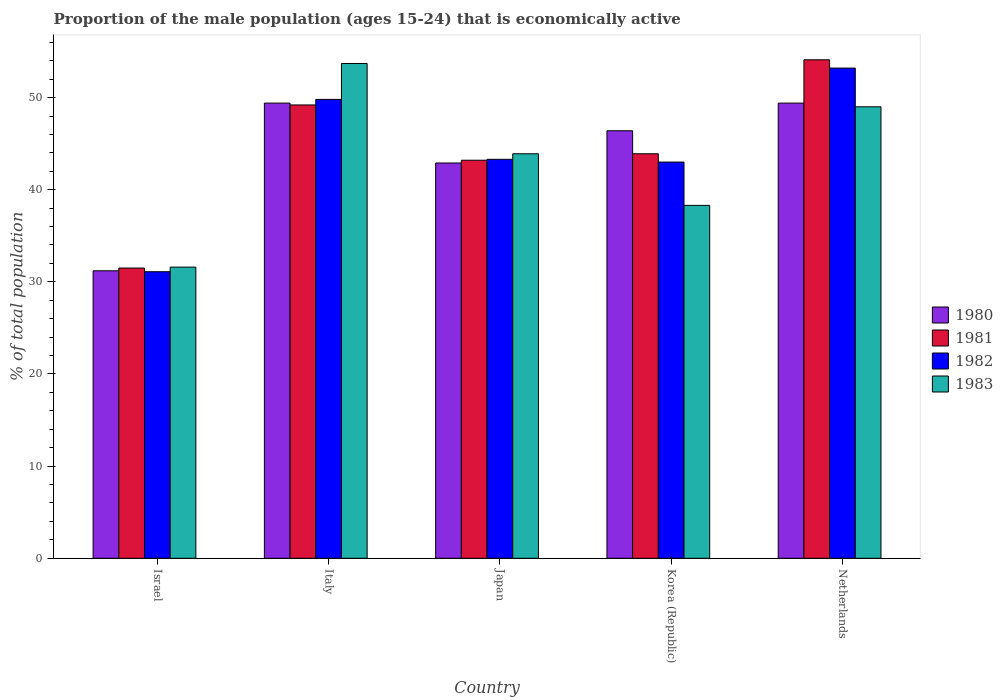How many groups of bars are there?
Offer a very short reply. 5. Are the number of bars per tick equal to the number of legend labels?
Your response must be concise. Yes. How many bars are there on the 1st tick from the left?
Your response must be concise. 4. What is the label of the 2nd group of bars from the left?
Your answer should be very brief. Italy. In how many cases, is the number of bars for a given country not equal to the number of legend labels?
Offer a terse response. 0. Across all countries, what is the maximum proportion of the male population that is economically active in 1981?
Make the answer very short. 54.1. Across all countries, what is the minimum proportion of the male population that is economically active in 1982?
Offer a terse response. 31.1. In which country was the proportion of the male population that is economically active in 1982 maximum?
Your response must be concise. Netherlands. What is the total proportion of the male population that is economically active in 1980 in the graph?
Make the answer very short. 219.3. What is the difference between the proportion of the male population that is economically active in 1980 in Israel and that in Japan?
Your answer should be compact. -11.7. What is the difference between the proportion of the male population that is economically active in 1983 in Netherlands and the proportion of the male population that is economically active in 1981 in Italy?
Offer a very short reply. -0.2. What is the average proportion of the male population that is economically active in 1980 per country?
Ensure brevity in your answer.  43.86. What is the difference between the proportion of the male population that is economically active of/in 1983 and proportion of the male population that is economically active of/in 1982 in Korea (Republic)?
Provide a short and direct response. -4.7. What is the ratio of the proportion of the male population that is economically active in 1982 in Italy to that in Netherlands?
Provide a succinct answer. 0.94. Is the proportion of the male population that is economically active in 1981 in Italy less than that in Japan?
Keep it short and to the point. No. Is the difference between the proportion of the male population that is economically active in 1983 in Israel and Japan greater than the difference between the proportion of the male population that is economically active in 1982 in Israel and Japan?
Provide a short and direct response. No. What is the difference between the highest and the second highest proportion of the male population that is economically active in 1982?
Ensure brevity in your answer.  6.5. What is the difference between the highest and the lowest proportion of the male population that is economically active in 1980?
Ensure brevity in your answer.  18.2. In how many countries, is the proportion of the male population that is economically active in 1982 greater than the average proportion of the male population that is economically active in 1982 taken over all countries?
Provide a short and direct response. 2. Is it the case that in every country, the sum of the proportion of the male population that is economically active in 1982 and proportion of the male population that is economically active in 1981 is greater than the sum of proportion of the male population that is economically active in 1983 and proportion of the male population that is economically active in 1980?
Make the answer very short. No. What does the 4th bar from the left in Japan represents?
Provide a short and direct response. 1983. What does the 3rd bar from the right in Korea (Republic) represents?
Your answer should be compact. 1981. Are all the bars in the graph horizontal?
Provide a succinct answer. No. Are the values on the major ticks of Y-axis written in scientific E-notation?
Provide a succinct answer. No. Does the graph contain any zero values?
Keep it short and to the point. No. Where does the legend appear in the graph?
Keep it short and to the point. Center right. How are the legend labels stacked?
Offer a terse response. Vertical. What is the title of the graph?
Keep it short and to the point. Proportion of the male population (ages 15-24) that is economically active. What is the label or title of the X-axis?
Your answer should be compact. Country. What is the label or title of the Y-axis?
Your response must be concise. % of total population. What is the % of total population of 1980 in Israel?
Offer a terse response. 31.2. What is the % of total population in 1981 in Israel?
Your answer should be compact. 31.5. What is the % of total population in 1982 in Israel?
Your response must be concise. 31.1. What is the % of total population of 1983 in Israel?
Provide a succinct answer. 31.6. What is the % of total population in 1980 in Italy?
Provide a short and direct response. 49.4. What is the % of total population in 1981 in Italy?
Your answer should be compact. 49.2. What is the % of total population in 1982 in Italy?
Your answer should be very brief. 49.8. What is the % of total population of 1983 in Italy?
Ensure brevity in your answer.  53.7. What is the % of total population in 1980 in Japan?
Provide a succinct answer. 42.9. What is the % of total population in 1981 in Japan?
Your answer should be very brief. 43.2. What is the % of total population in 1982 in Japan?
Your answer should be compact. 43.3. What is the % of total population of 1983 in Japan?
Your response must be concise. 43.9. What is the % of total population in 1980 in Korea (Republic)?
Provide a succinct answer. 46.4. What is the % of total population in 1981 in Korea (Republic)?
Offer a terse response. 43.9. What is the % of total population in 1983 in Korea (Republic)?
Ensure brevity in your answer.  38.3. What is the % of total population in 1980 in Netherlands?
Ensure brevity in your answer.  49.4. What is the % of total population in 1981 in Netherlands?
Your answer should be very brief. 54.1. What is the % of total population in 1982 in Netherlands?
Give a very brief answer. 53.2. What is the % of total population of 1983 in Netherlands?
Make the answer very short. 49. Across all countries, what is the maximum % of total population of 1980?
Your response must be concise. 49.4. Across all countries, what is the maximum % of total population of 1981?
Offer a very short reply. 54.1. Across all countries, what is the maximum % of total population in 1982?
Ensure brevity in your answer.  53.2. Across all countries, what is the maximum % of total population of 1983?
Offer a very short reply. 53.7. Across all countries, what is the minimum % of total population in 1980?
Provide a short and direct response. 31.2. Across all countries, what is the minimum % of total population of 1981?
Keep it short and to the point. 31.5. Across all countries, what is the minimum % of total population in 1982?
Provide a short and direct response. 31.1. Across all countries, what is the minimum % of total population in 1983?
Offer a terse response. 31.6. What is the total % of total population in 1980 in the graph?
Your response must be concise. 219.3. What is the total % of total population in 1981 in the graph?
Offer a very short reply. 221.9. What is the total % of total population in 1982 in the graph?
Your answer should be very brief. 220.4. What is the total % of total population in 1983 in the graph?
Ensure brevity in your answer.  216.5. What is the difference between the % of total population in 1980 in Israel and that in Italy?
Ensure brevity in your answer.  -18.2. What is the difference between the % of total population of 1981 in Israel and that in Italy?
Give a very brief answer. -17.7. What is the difference between the % of total population of 1982 in Israel and that in Italy?
Your response must be concise. -18.7. What is the difference between the % of total population of 1983 in Israel and that in Italy?
Your response must be concise. -22.1. What is the difference between the % of total population in 1982 in Israel and that in Japan?
Ensure brevity in your answer.  -12.2. What is the difference between the % of total population in 1983 in Israel and that in Japan?
Give a very brief answer. -12.3. What is the difference between the % of total population of 1980 in Israel and that in Korea (Republic)?
Keep it short and to the point. -15.2. What is the difference between the % of total population in 1981 in Israel and that in Korea (Republic)?
Your answer should be compact. -12.4. What is the difference between the % of total population in 1982 in Israel and that in Korea (Republic)?
Make the answer very short. -11.9. What is the difference between the % of total population in 1983 in Israel and that in Korea (Republic)?
Your answer should be compact. -6.7. What is the difference between the % of total population of 1980 in Israel and that in Netherlands?
Provide a short and direct response. -18.2. What is the difference between the % of total population in 1981 in Israel and that in Netherlands?
Ensure brevity in your answer.  -22.6. What is the difference between the % of total population in 1982 in Israel and that in Netherlands?
Provide a succinct answer. -22.1. What is the difference between the % of total population of 1983 in Israel and that in Netherlands?
Make the answer very short. -17.4. What is the difference between the % of total population of 1981 in Italy and that in Japan?
Provide a short and direct response. 6. What is the difference between the % of total population in 1982 in Italy and that in Japan?
Keep it short and to the point. 6.5. What is the difference between the % of total population in 1983 in Italy and that in Japan?
Make the answer very short. 9.8. What is the difference between the % of total population in 1980 in Italy and that in Korea (Republic)?
Ensure brevity in your answer.  3. What is the difference between the % of total population of 1982 in Italy and that in Korea (Republic)?
Ensure brevity in your answer.  6.8. What is the difference between the % of total population of 1982 in Italy and that in Netherlands?
Make the answer very short. -3.4. What is the difference between the % of total population in 1983 in Italy and that in Netherlands?
Your answer should be very brief. 4.7. What is the difference between the % of total population in 1980 in Japan and that in Korea (Republic)?
Offer a very short reply. -3.5. What is the difference between the % of total population in 1982 in Japan and that in Korea (Republic)?
Offer a terse response. 0.3. What is the difference between the % of total population of 1983 in Japan and that in Korea (Republic)?
Your answer should be compact. 5.6. What is the difference between the % of total population in 1980 in Japan and that in Netherlands?
Make the answer very short. -6.5. What is the difference between the % of total population of 1981 in Japan and that in Netherlands?
Your response must be concise. -10.9. What is the difference between the % of total population of 1982 in Japan and that in Netherlands?
Provide a short and direct response. -9.9. What is the difference between the % of total population of 1983 in Japan and that in Netherlands?
Ensure brevity in your answer.  -5.1. What is the difference between the % of total population in 1980 in Korea (Republic) and that in Netherlands?
Offer a very short reply. -3. What is the difference between the % of total population in 1982 in Korea (Republic) and that in Netherlands?
Ensure brevity in your answer.  -10.2. What is the difference between the % of total population of 1983 in Korea (Republic) and that in Netherlands?
Provide a succinct answer. -10.7. What is the difference between the % of total population in 1980 in Israel and the % of total population in 1981 in Italy?
Ensure brevity in your answer.  -18. What is the difference between the % of total population in 1980 in Israel and the % of total population in 1982 in Italy?
Keep it short and to the point. -18.6. What is the difference between the % of total population in 1980 in Israel and the % of total population in 1983 in Italy?
Your answer should be very brief. -22.5. What is the difference between the % of total population of 1981 in Israel and the % of total population of 1982 in Italy?
Your answer should be very brief. -18.3. What is the difference between the % of total population in 1981 in Israel and the % of total population in 1983 in Italy?
Your answer should be compact. -22.2. What is the difference between the % of total population of 1982 in Israel and the % of total population of 1983 in Italy?
Give a very brief answer. -22.6. What is the difference between the % of total population in 1980 in Israel and the % of total population in 1982 in Japan?
Ensure brevity in your answer.  -12.1. What is the difference between the % of total population in 1981 in Israel and the % of total population in 1982 in Japan?
Offer a terse response. -11.8. What is the difference between the % of total population in 1982 in Israel and the % of total population in 1983 in Japan?
Offer a very short reply. -12.8. What is the difference between the % of total population of 1980 in Israel and the % of total population of 1981 in Korea (Republic)?
Your response must be concise. -12.7. What is the difference between the % of total population in 1980 in Israel and the % of total population in 1983 in Korea (Republic)?
Ensure brevity in your answer.  -7.1. What is the difference between the % of total population of 1981 in Israel and the % of total population of 1982 in Korea (Republic)?
Make the answer very short. -11.5. What is the difference between the % of total population in 1981 in Israel and the % of total population in 1983 in Korea (Republic)?
Offer a terse response. -6.8. What is the difference between the % of total population of 1982 in Israel and the % of total population of 1983 in Korea (Republic)?
Offer a terse response. -7.2. What is the difference between the % of total population of 1980 in Israel and the % of total population of 1981 in Netherlands?
Your answer should be compact. -22.9. What is the difference between the % of total population in 1980 in Israel and the % of total population in 1983 in Netherlands?
Ensure brevity in your answer.  -17.8. What is the difference between the % of total population in 1981 in Israel and the % of total population in 1982 in Netherlands?
Ensure brevity in your answer.  -21.7. What is the difference between the % of total population in 1981 in Israel and the % of total population in 1983 in Netherlands?
Make the answer very short. -17.5. What is the difference between the % of total population of 1982 in Israel and the % of total population of 1983 in Netherlands?
Your answer should be very brief. -17.9. What is the difference between the % of total population of 1980 in Italy and the % of total population of 1981 in Japan?
Offer a very short reply. 6.2. What is the difference between the % of total population in 1980 in Italy and the % of total population in 1983 in Japan?
Give a very brief answer. 5.5. What is the difference between the % of total population of 1982 in Italy and the % of total population of 1983 in Japan?
Your answer should be very brief. 5.9. What is the difference between the % of total population in 1980 in Italy and the % of total population in 1983 in Korea (Republic)?
Your response must be concise. 11.1. What is the difference between the % of total population of 1981 in Italy and the % of total population of 1983 in Korea (Republic)?
Your answer should be compact. 10.9. What is the difference between the % of total population of 1982 in Italy and the % of total population of 1983 in Korea (Republic)?
Ensure brevity in your answer.  11.5. What is the difference between the % of total population of 1980 in Italy and the % of total population of 1981 in Netherlands?
Your answer should be compact. -4.7. What is the difference between the % of total population of 1980 in Italy and the % of total population of 1983 in Netherlands?
Make the answer very short. 0.4. What is the difference between the % of total population of 1981 in Italy and the % of total population of 1983 in Netherlands?
Provide a short and direct response. 0.2. What is the difference between the % of total population in 1980 in Japan and the % of total population in 1981 in Korea (Republic)?
Keep it short and to the point. -1. What is the difference between the % of total population of 1981 in Japan and the % of total population of 1982 in Korea (Republic)?
Your response must be concise. 0.2. What is the difference between the % of total population of 1982 in Japan and the % of total population of 1983 in Korea (Republic)?
Ensure brevity in your answer.  5. What is the difference between the % of total population in 1980 in Japan and the % of total population in 1982 in Netherlands?
Provide a short and direct response. -10.3. What is the difference between the % of total population in 1980 in Japan and the % of total population in 1983 in Netherlands?
Your answer should be very brief. -6.1. What is the difference between the % of total population in 1982 in Japan and the % of total population in 1983 in Netherlands?
Provide a short and direct response. -5.7. What is the difference between the % of total population of 1980 in Korea (Republic) and the % of total population of 1982 in Netherlands?
Give a very brief answer. -6.8. What is the difference between the % of total population of 1981 in Korea (Republic) and the % of total population of 1982 in Netherlands?
Keep it short and to the point. -9.3. What is the difference between the % of total population of 1982 in Korea (Republic) and the % of total population of 1983 in Netherlands?
Keep it short and to the point. -6. What is the average % of total population in 1980 per country?
Make the answer very short. 43.86. What is the average % of total population of 1981 per country?
Give a very brief answer. 44.38. What is the average % of total population in 1982 per country?
Your response must be concise. 44.08. What is the average % of total population of 1983 per country?
Give a very brief answer. 43.3. What is the difference between the % of total population in 1981 and % of total population in 1983 in Israel?
Make the answer very short. -0.1. What is the difference between the % of total population in 1982 and % of total population in 1983 in Israel?
Your response must be concise. -0.5. What is the difference between the % of total population of 1980 and % of total population of 1981 in Italy?
Ensure brevity in your answer.  0.2. What is the difference between the % of total population in 1981 and % of total population in 1982 in Italy?
Provide a succinct answer. -0.6. What is the difference between the % of total population of 1982 and % of total population of 1983 in Italy?
Ensure brevity in your answer.  -3.9. What is the difference between the % of total population of 1980 and % of total population of 1981 in Japan?
Your answer should be very brief. -0.3. What is the difference between the % of total population in 1980 and % of total population in 1982 in Japan?
Provide a short and direct response. -0.4. What is the difference between the % of total population of 1980 and % of total population of 1983 in Japan?
Give a very brief answer. -1. What is the difference between the % of total population of 1981 and % of total population of 1982 in Japan?
Offer a very short reply. -0.1. What is the difference between the % of total population of 1981 and % of total population of 1983 in Japan?
Give a very brief answer. -0.7. What is the difference between the % of total population in 1982 and % of total population in 1983 in Japan?
Your answer should be very brief. -0.6. What is the difference between the % of total population in 1980 and % of total population in 1982 in Korea (Republic)?
Offer a terse response. 3.4. What is the difference between the % of total population in 1980 and % of total population in 1983 in Korea (Republic)?
Keep it short and to the point. 8.1. What is the difference between the % of total population of 1981 and % of total population of 1982 in Korea (Republic)?
Provide a short and direct response. 0.9. What is the difference between the % of total population in 1981 and % of total population in 1983 in Korea (Republic)?
Make the answer very short. 5.6. What is the difference between the % of total population of 1980 and % of total population of 1981 in Netherlands?
Offer a terse response. -4.7. What is the difference between the % of total population of 1980 and % of total population of 1983 in Netherlands?
Your answer should be very brief. 0.4. What is the difference between the % of total population of 1981 and % of total population of 1982 in Netherlands?
Your answer should be very brief. 0.9. What is the difference between the % of total population of 1981 and % of total population of 1983 in Netherlands?
Your answer should be compact. 5.1. What is the difference between the % of total population of 1982 and % of total population of 1983 in Netherlands?
Your answer should be compact. 4.2. What is the ratio of the % of total population of 1980 in Israel to that in Italy?
Offer a very short reply. 0.63. What is the ratio of the % of total population of 1981 in Israel to that in Italy?
Keep it short and to the point. 0.64. What is the ratio of the % of total population of 1982 in Israel to that in Italy?
Your answer should be compact. 0.62. What is the ratio of the % of total population of 1983 in Israel to that in Italy?
Keep it short and to the point. 0.59. What is the ratio of the % of total population in 1980 in Israel to that in Japan?
Ensure brevity in your answer.  0.73. What is the ratio of the % of total population in 1981 in Israel to that in Japan?
Your answer should be compact. 0.73. What is the ratio of the % of total population of 1982 in Israel to that in Japan?
Provide a succinct answer. 0.72. What is the ratio of the % of total population in 1983 in Israel to that in Japan?
Ensure brevity in your answer.  0.72. What is the ratio of the % of total population of 1980 in Israel to that in Korea (Republic)?
Provide a succinct answer. 0.67. What is the ratio of the % of total population of 1981 in Israel to that in Korea (Republic)?
Ensure brevity in your answer.  0.72. What is the ratio of the % of total population of 1982 in Israel to that in Korea (Republic)?
Provide a succinct answer. 0.72. What is the ratio of the % of total population in 1983 in Israel to that in Korea (Republic)?
Your response must be concise. 0.83. What is the ratio of the % of total population of 1980 in Israel to that in Netherlands?
Offer a terse response. 0.63. What is the ratio of the % of total population of 1981 in Israel to that in Netherlands?
Ensure brevity in your answer.  0.58. What is the ratio of the % of total population in 1982 in Israel to that in Netherlands?
Keep it short and to the point. 0.58. What is the ratio of the % of total population in 1983 in Israel to that in Netherlands?
Offer a terse response. 0.64. What is the ratio of the % of total population of 1980 in Italy to that in Japan?
Make the answer very short. 1.15. What is the ratio of the % of total population of 1981 in Italy to that in Japan?
Provide a short and direct response. 1.14. What is the ratio of the % of total population in 1982 in Italy to that in Japan?
Give a very brief answer. 1.15. What is the ratio of the % of total population of 1983 in Italy to that in Japan?
Keep it short and to the point. 1.22. What is the ratio of the % of total population of 1980 in Italy to that in Korea (Republic)?
Ensure brevity in your answer.  1.06. What is the ratio of the % of total population of 1981 in Italy to that in Korea (Republic)?
Make the answer very short. 1.12. What is the ratio of the % of total population of 1982 in Italy to that in Korea (Republic)?
Provide a succinct answer. 1.16. What is the ratio of the % of total population of 1983 in Italy to that in Korea (Republic)?
Make the answer very short. 1.4. What is the ratio of the % of total population of 1981 in Italy to that in Netherlands?
Offer a very short reply. 0.91. What is the ratio of the % of total population in 1982 in Italy to that in Netherlands?
Your response must be concise. 0.94. What is the ratio of the % of total population in 1983 in Italy to that in Netherlands?
Give a very brief answer. 1.1. What is the ratio of the % of total population of 1980 in Japan to that in Korea (Republic)?
Provide a succinct answer. 0.92. What is the ratio of the % of total population of 1981 in Japan to that in Korea (Republic)?
Your answer should be compact. 0.98. What is the ratio of the % of total population in 1983 in Japan to that in Korea (Republic)?
Ensure brevity in your answer.  1.15. What is the ratio of the % of total population in 1980 in Japan to that in Netherlands?
Give a very brief answer. 0.87. What is the ratio of the % of total population in 1981 in Japan to that in Netherlands?
Offer a very short reply. 0.8. What is the ratio of the % of total population in 1982 in Japan to that in Netherlands?
Offer a very short reply. 0.81. What is the ratio of the % of total population in 1983 in Japan to that in Netherlands?
Provide a short and direct response. 0.9. What is the ratio of the % of total population in 1980 in Korea (Republic) to that in Netherlands?
Your answer should be compact. 0.94. What is the ratio of the % of total population in 1981 in Korea (Republic) to that in Netherlands?
Your answer should be very brief. 0.81. What is the ratio of the % of total population of 1982 in Korea (Republic) to that in Netherlands?
Provide a succinct answer. 0.81. What is the ratio of the % of total population of 1983 in Korea (Republic) to that in Netherlands?
Make the answer very short. 0.78. What is the difference between the highest and the second highest % of total population in 1981?
Ensure brevity in your answer.  4.9. What is the difference between the highest and the second highest % of total population of 1982?
Your response must be concise. 3.4. What is the difference between the highest and the second highest % of total population in 1983?
Your answer should be compact. 4.7. What is the difference between the highest and the lowest % of total population of 1980?
Provide a succinct answer. 18.2. What is the difference between the highest and the lowest % of total population of 1981?
Keep it short and to the point. 22.6. What is the difference between the highest and the lowest % of total population in 1982?
Your response must be concise. 22.1. What is the difference between the highest and the lowest % of total population of 1983?
Your response must be concise. 22.1. 